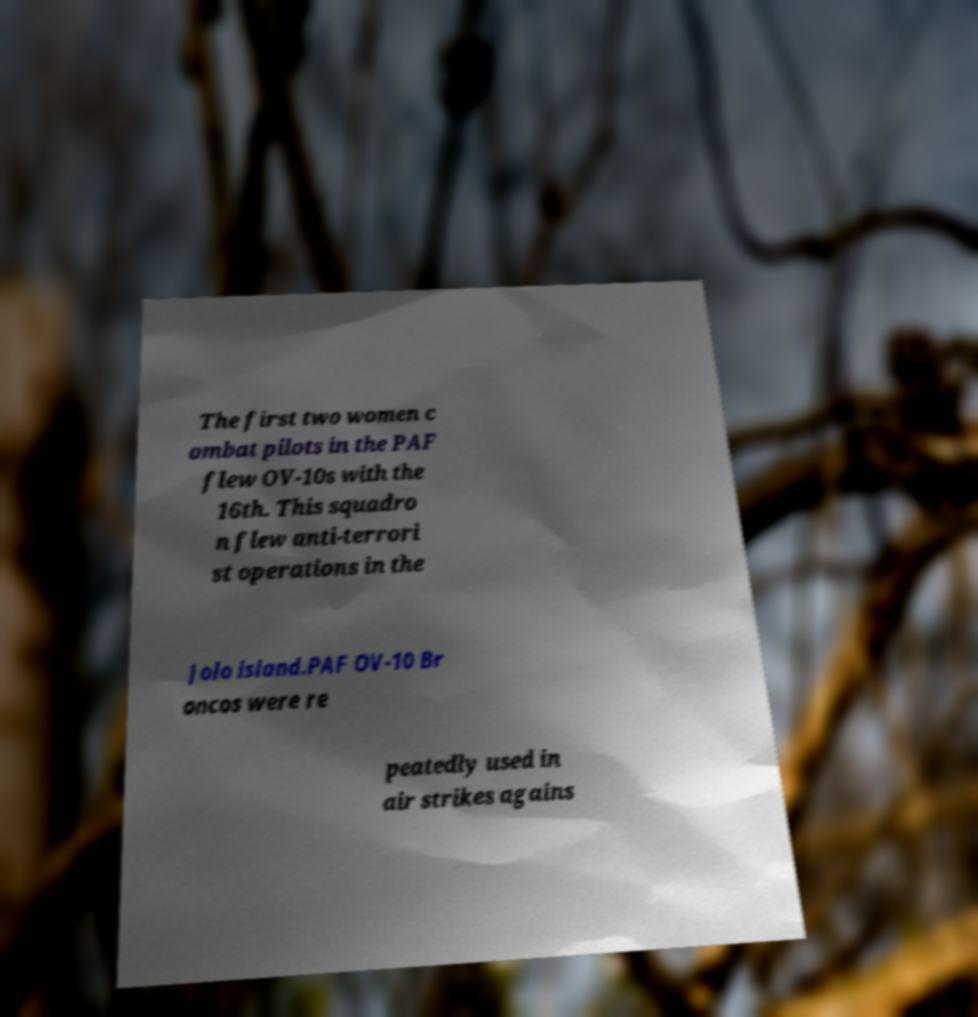Please identify and transcribe the text found in this image. The first two women c ombat pilots in the PAF flew OV-10s with the 16th. This squadro n flew anti-terrori st operations in the Jolo island.PAF OV-10 Br oncos were re peatedly used in air strikes agains 